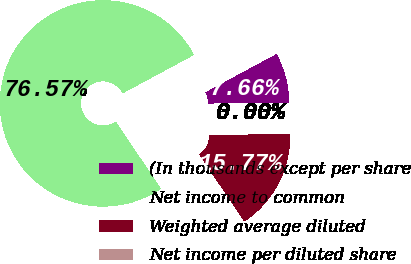Convert chart. <chart><loc_0><loc_0><loc_500><loc_500><pie_chart><fcel>(In thousands except per share<fcel>Net income to common<fcel>Weighted average diluted<fcel>Net income per diluted share<nl><fcel>7.66%<fcel>76.57%<fcel>15.77%<fcel>0.0%<nl></chart> 